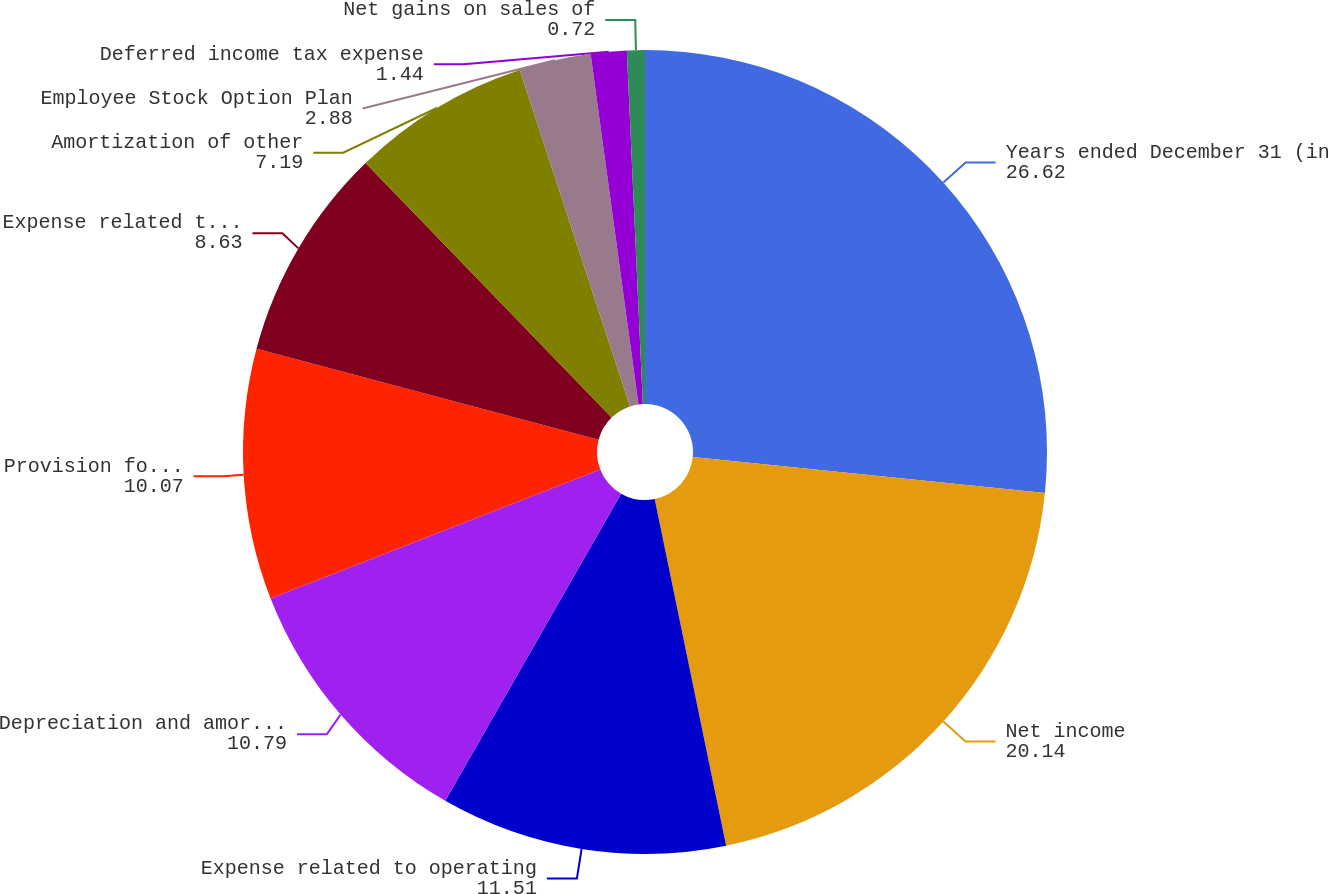<chart> <loc_0><loc_0><loc_500><loc_500><pie_chart><fcel>Years ended December 31 (in<fcel>Net income<fcel>Expense related to operating<fcel>Depreciation and amortization<fcel>Provision for loan losses<fcel>Expense related to share-based<fcel>Amortization of other<fcel>Employee Stock Option Plan<fcel>Deferred income tax expense<fcel>Net gains on sales of<nl><fcel>26.62%<fcel>20.14%<fcel>11.51%<fcel>10.79%<fcel>10.07%<fcel>8.63%<fcel>7.19%<fcel>2.88%<fcel>1.44%<fcel>0.72%<nl></chart> 